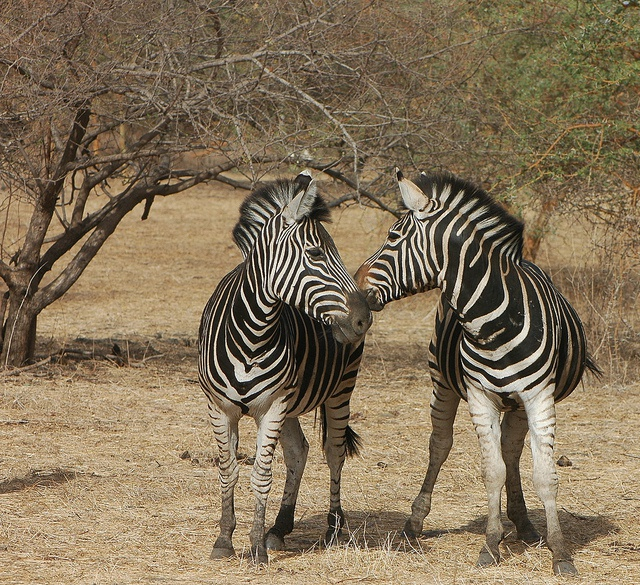Describe the objects in this image and their specific colors. I can see zebra in maroon, black, gray, and darkgray tones and zebra in maroon, black, gray, and darkgray tones in this image. 